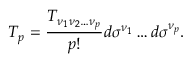<formula> <loc_0><loc_0><loc_500><loc_500>T _ { p } = { \frac { T _ { \nu _ { 1 } \nu _ { 2 } \dots \nu _ { p } } } { p ! } } d \sigma ^ { \nu _ { 1 } } \dots d \sigma ^ { \nu _ { p } } .</formula> 